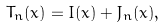<formula> <loc_0><loc_0><loc_500><loc_500>T _ { n } ( x ) = I ( x ) + J _ { n } ( x ) ,</formula> 